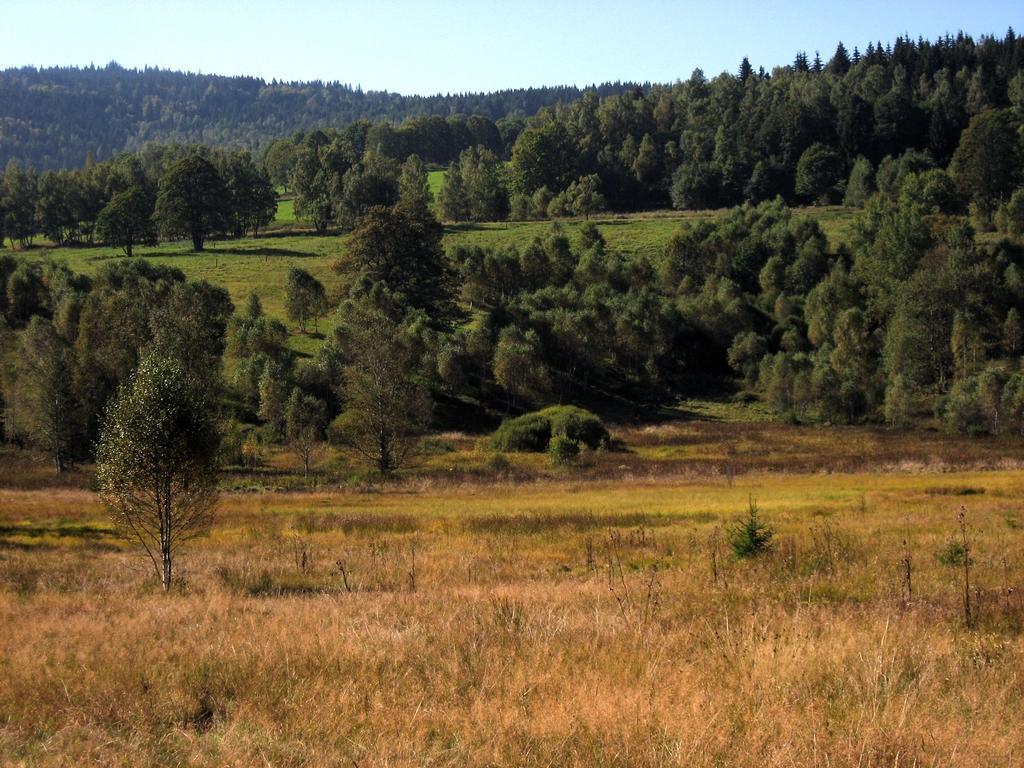How would you summarize this image in a sentence or two? In this image, we can see the ground. We can see some grass, plants and trees. We can see some hills and the sky. 